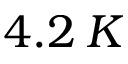Convert formula to latex. <formula><loc_0><loc_0><loc_500><loc_500>4 . 2 \, K</formula> 